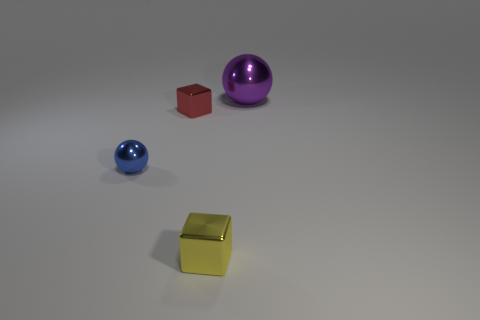Add 3 balls. How many objects exist? 7 Subtract all blue blocks. Subtract all green balls. How many blocks are left? 2 Subtract all large purple things. Subtract all big yellow cylinders. How many objects are left? 3 Add 1 red things. How many red things are left? 2 Add 1 purple shiny things. How many purple shiny things exist? 2 Subtract 0 red balls. How many objects are left? 4 Subtract 1 cubes. How many cubes are left? 1 